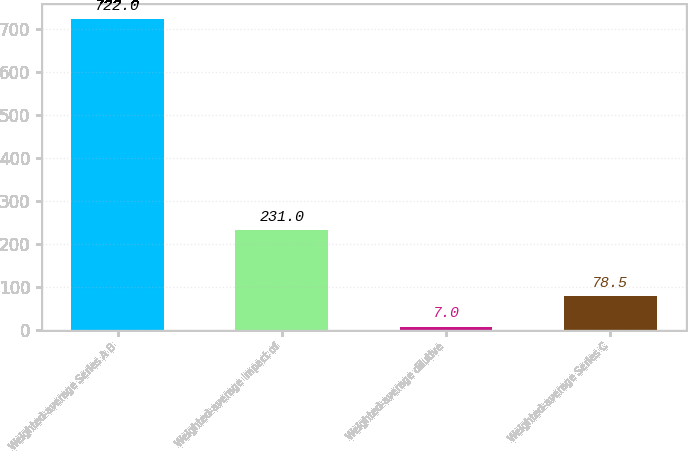Convert chart. <chart><loc_0><loc_0><loc_500><loc_500><bar_chart><fcel>Weighted-average Series A B<fcel>Weighted-average impact of<fcel>Weighted-average dilutive<fcel>Weighted-average Series C<nl><fcel>722<fcel>231<fcel>7<fcel>78.5<nl></chart> 